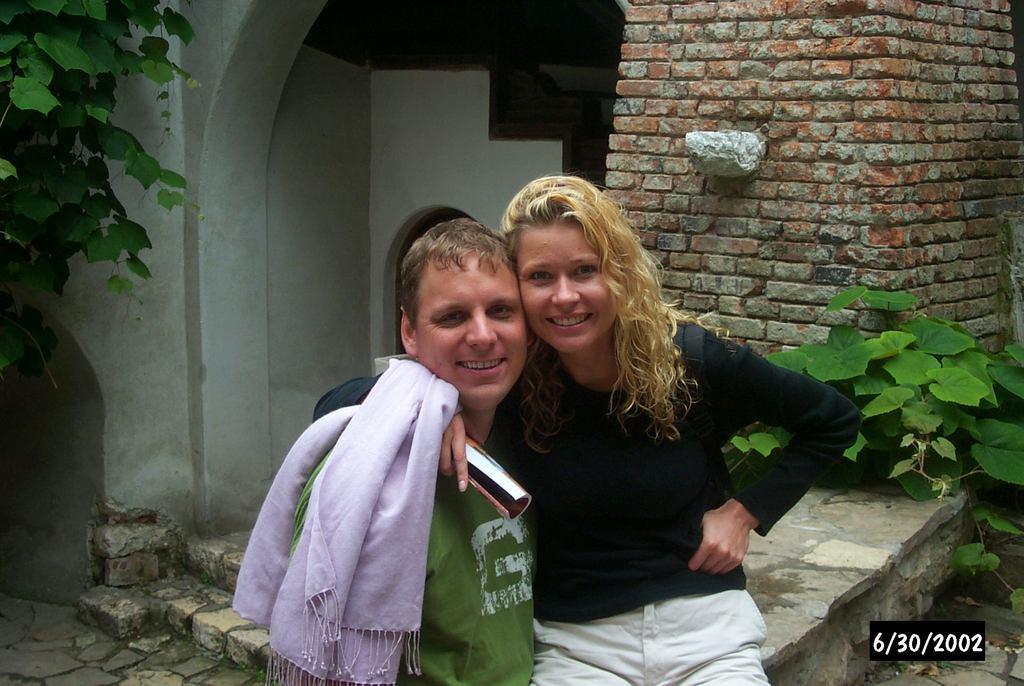In one or two sentences, can you explain what this image depicts? In this image we can see two people. One woman is sitting on the surface holding a book in her hand. On the right side of the image we can see some plants. On the left side of the image we can see stairs. At the top of the image we can see a building. 